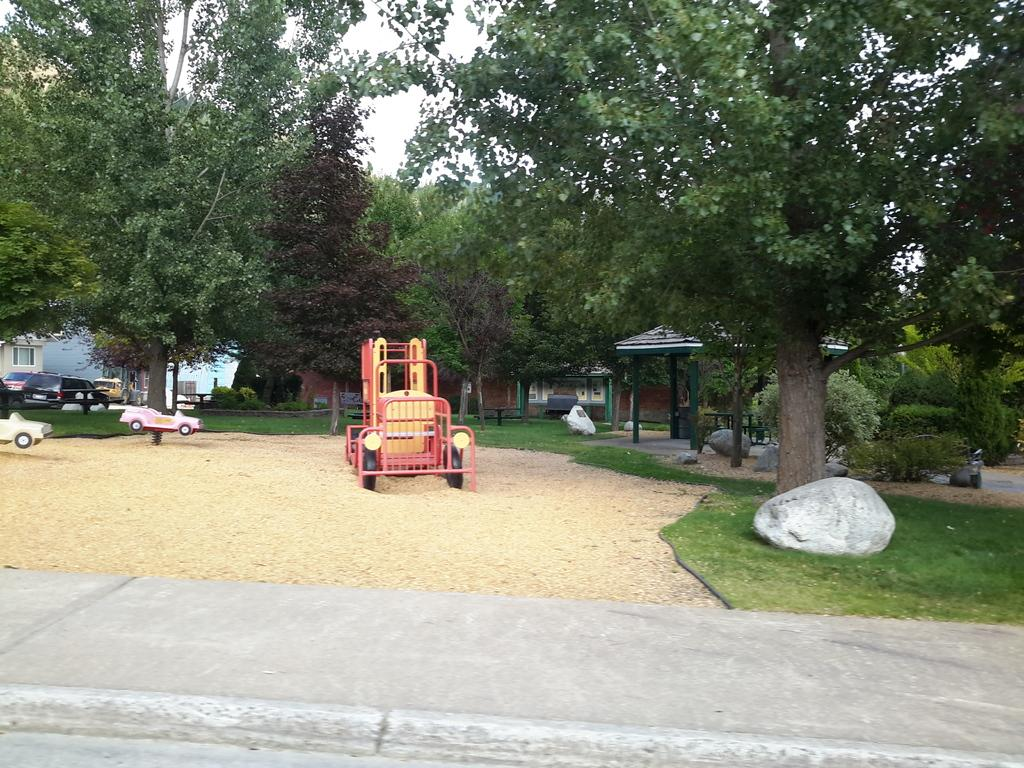What objects are on the soil in the image? There are toys on the soil in the image. What type of vegetation is present on the surface? Grass is present on the surface. What can be seen in the background of the image? There are trees and buildings in the background of the image. What type of vehicles are parked on the ground in the background of the image? Cars are parked on the ground in the background of the image. What color is the shade of underwear worn by the trees in the image? There is no underwear present in the image, as the trees are not wearing any clothing. How much powder is visible on the surface of the grass in the image? There is no powder visible on the surface of the grass in the image. 